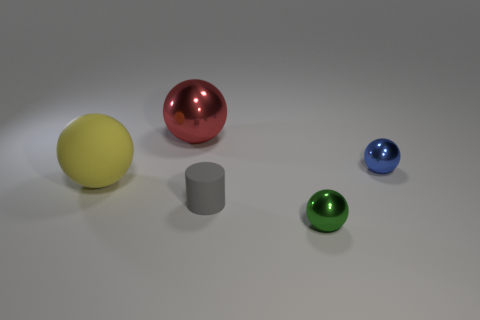Subtract all green metal spheres. How many spheres are left? 3 Subtract 3 balls. How many balls are left? 1 Subtract all gray spheres. Subtract all yellow cylinders. How many spheres are left? 4 Subtract all yellow cubes. How many purple spheres are left? 0 Subtract all big red rubber spheres. Subtract all small matte cylinders. How many objects are left? 4 Add 5 tiny gray objects. How many tiny gray objects are left? 6 Add 3 small metallic objects. How many small metallic objects exist? 5 Add 2 tiny green metallic spheres. How many objects exist? 7 Subtract all yellow spheres. How many spheres are left? 3 Subtract 0 cyan blocks. How many objects are left? 5 